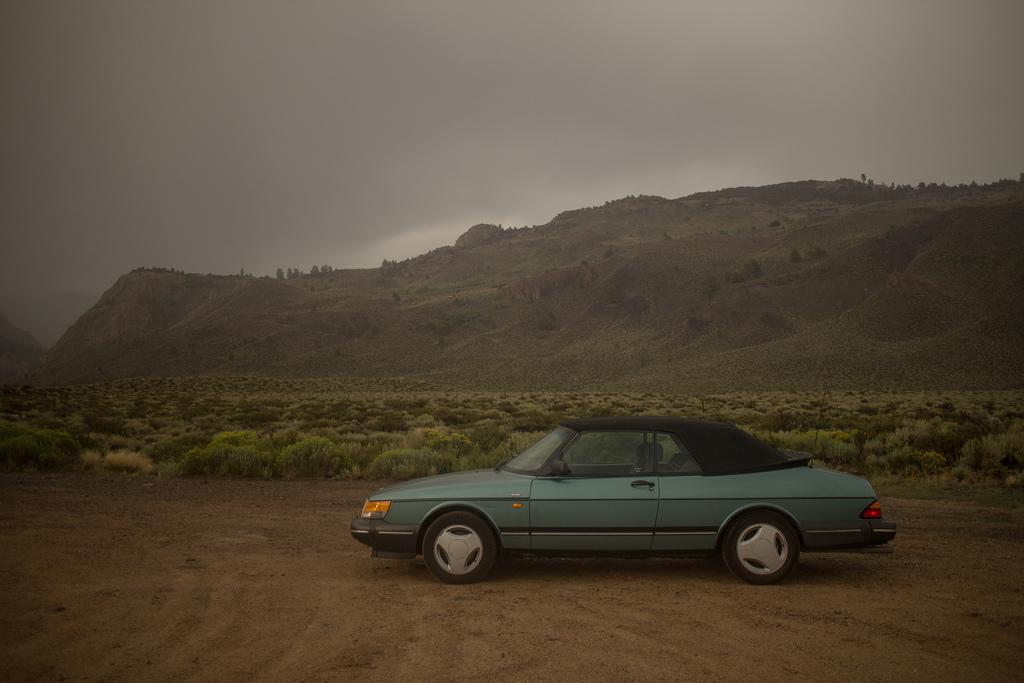What is the main subject of the image? There is a car in the image. What can be seen in the background of the image? There is a mountain, trees, plants, and the sky visible in the background of the image. What type of shoe can be seen on the car's dashboard in the image? There is no shoe present on the car's dashboard in the image. Is there a plane flying in the sky in the image? There is no plane visible in the sky in the image. 